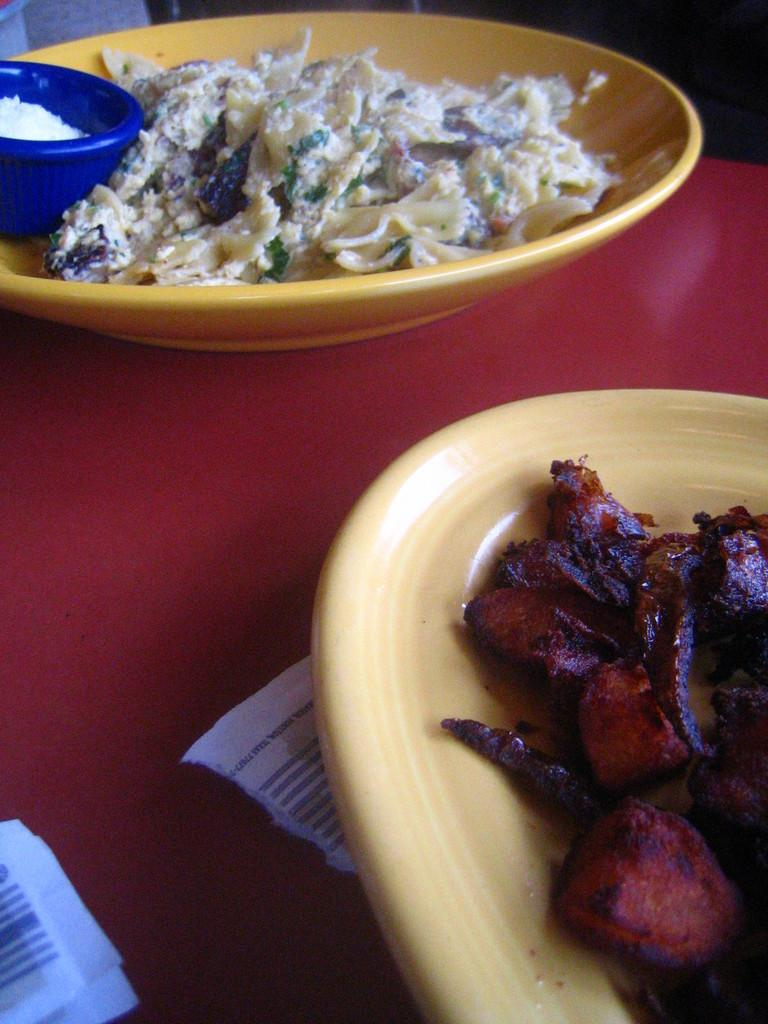What objects are present on the table in the image? There are serving plates in the image. What is on the serving plates? The serving plates have food on them. Where are the serving plates located? The serving plates are placed on a table. What type of feeling can be seen on the serving plates in the image? There are no feelings present on the serving plates in the image; they are objects used for serving food. 